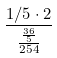Convert formula to latex. <formula><loc_0><loc_0><loc_500><loc_500>\frac { 1 / 5 \cdot 2 } { \frac { \frac { 3 6 } { 5 } } { 2 5 4 } }</formula> 